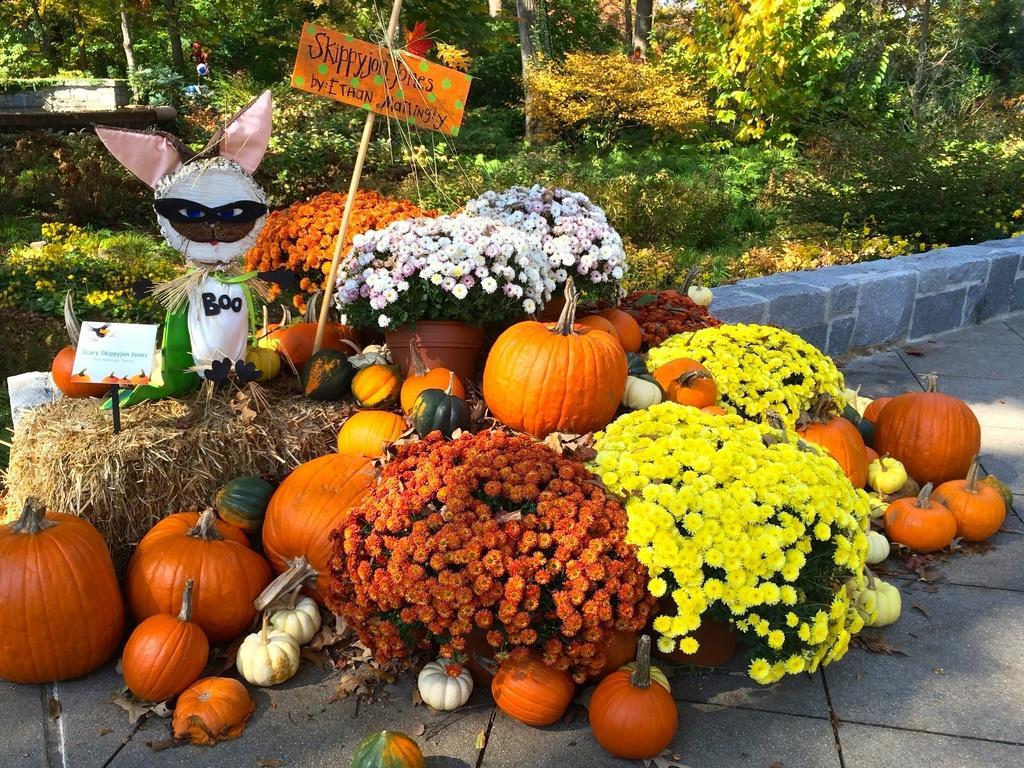Describe this image in one or two sentences. In this picture I can see pumpkins on the left and right side. I can see the flowers. I can see trees in the background. 